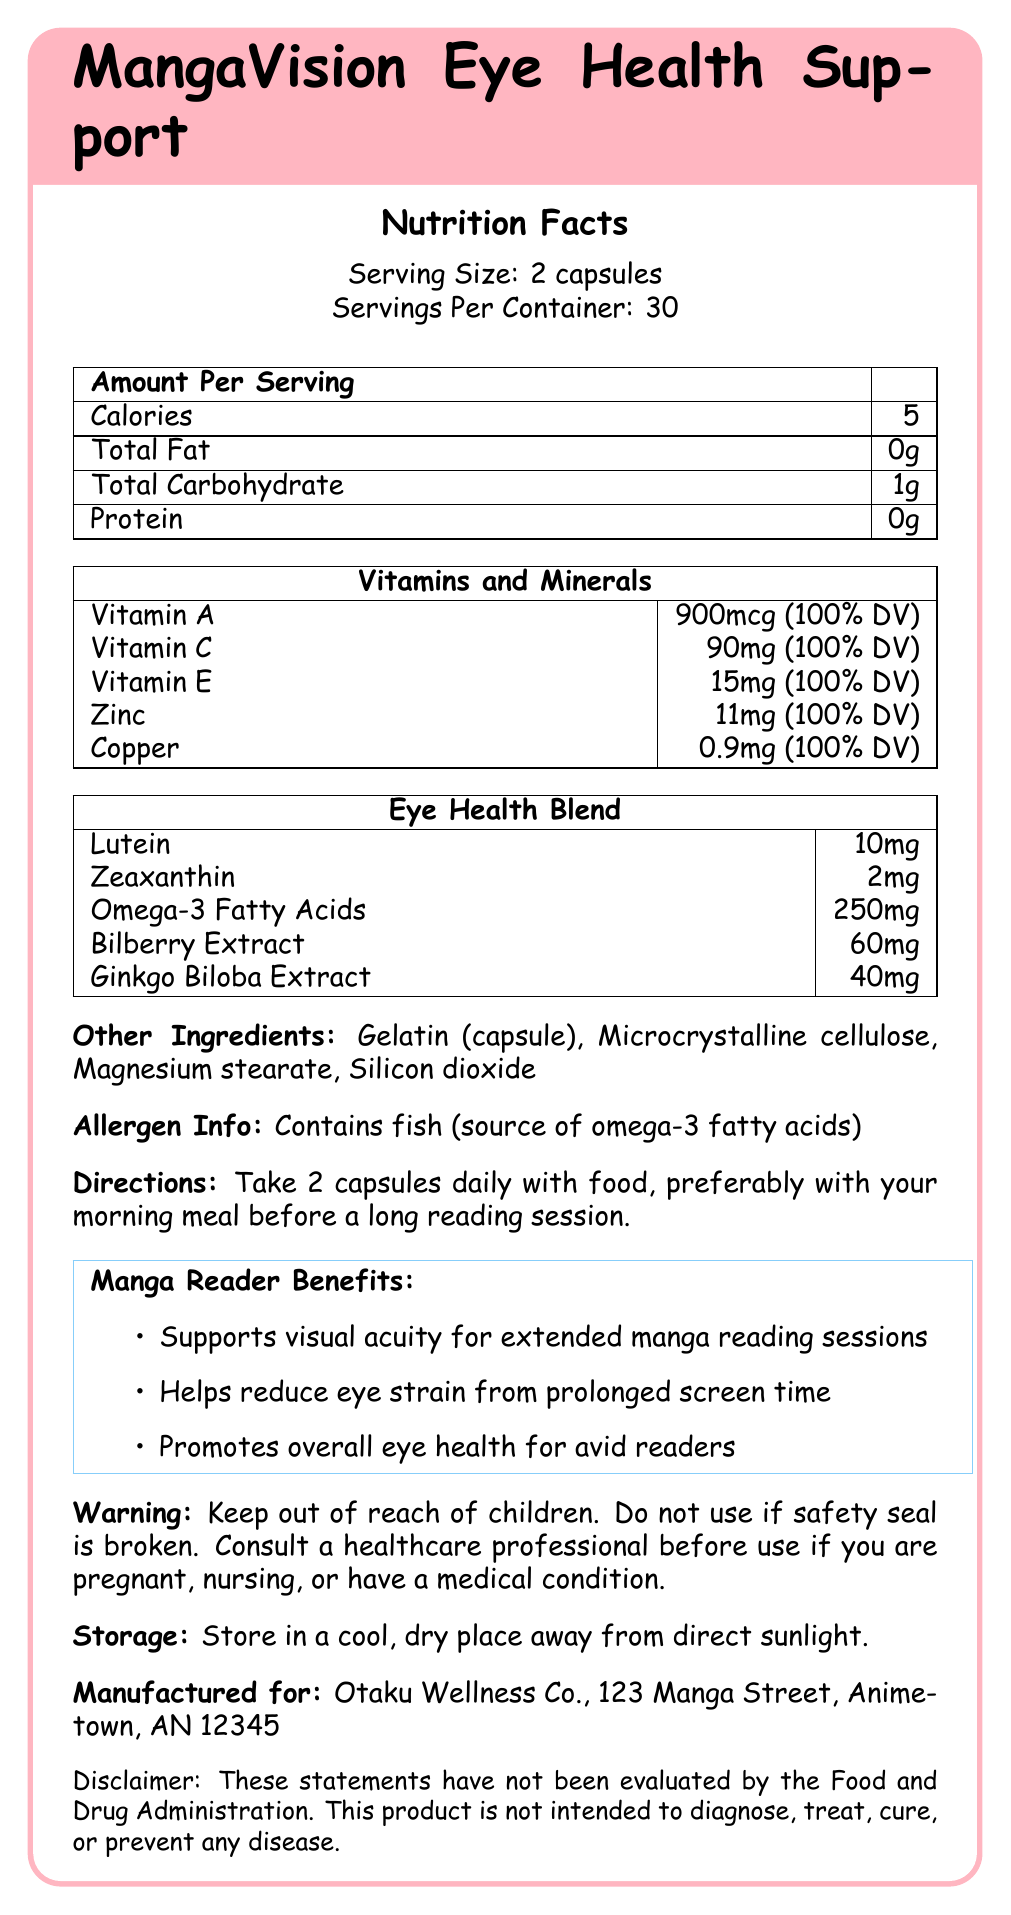what is the name of the product? The product name is clearly stated at the top of the document as MangaVision Eye Health Support.
Answer: MangaVision Eye Health Support how many calories are there per serving? The document lists the number of calories per serving in the nutrition facts section as 5.
Answer: 5 what is the serving size? The serving size is given in the nutrition facts as 2 capsules.
Answer: 2 capsules how many servings per container? The document states that there are 30 servings per container.
Answer: 30 what is the amount of Vitamin A per serving? The amount of Vitamin A per serving is listed as 900mcg, which is 100% of the daily value.
Answer: 900mcg (100% DV) which ingredient is used as a source of omega-3 fatty acids? A. Bilberry Extract B. Fish C. Ginkgo Biloba Extract The document specifies that the allergen info states the product contains fish, which is the source of omega-3 fatty acids.
Answer: B how much zinc is in each serving of this supplement? A. 5mg B. 11mg C. 15mg D. 20mg According to the vitamins and minerals section, each serving contains 11mg of zinc.
Answer: B does the product contain iron? There is no mention of iron in the list of vitamins, minerals, and other ingredients listed in the document.
Answer: No what are the benefits of this supplement for manga readers? The document lists these benefits specifically for manga readers in the Manga Reader Benefits section.
Answer: Supports visual acuity, helps reduce eye strain, promotes overall eye health describe the main purpose of this supplement. The supplement includes various vitamins and minerals (like Vitamin A, C, E, zinc, and copper) alongside an eye health blend (like lutein and zeaxanthin) specifically designed for avid readers to support their eye health.
Answer: The main purpose of this supplement is to support eye health for avid readers, especially those who spend long periods reading manga. It contains various vitamins, minerals, and eye health-specific ingredients to reduce eye strain and support visual acuity. what is the recommended daily dosage for this supplement? The document provides specific directions to take 2 capsules daily with food, preferably with a morning meal.
Answer: 2 capsules daily with food, preferably with your morning meal who manufactures MangaVision Eye Health Support? The manufacturer information is listed at the bottom of the document.
Answer: Otaku Wellness Co., 123 Manga Street, Animetown, AN 12345 is the safety seal important for this product? The warning section advises not to use the product if the safety seal is broken, emphasizing its importance.
Answer: Yes where should this supplement be stored? The storage instructions at the bottom of the document specify to store it in a cool, dry place away from direct sunlight.
Answer: In a cool, dry place away from direct sunlight. are there any usage warnings for pregnant women? The document advises consulting a healthcare professional before use if you are pregnant, nursing, or have a medical condition.
Answer: Yes does this supplement contain gluten? The document does not provide information regarding whether the product contains gluten or not.
Answer: Not enough information 